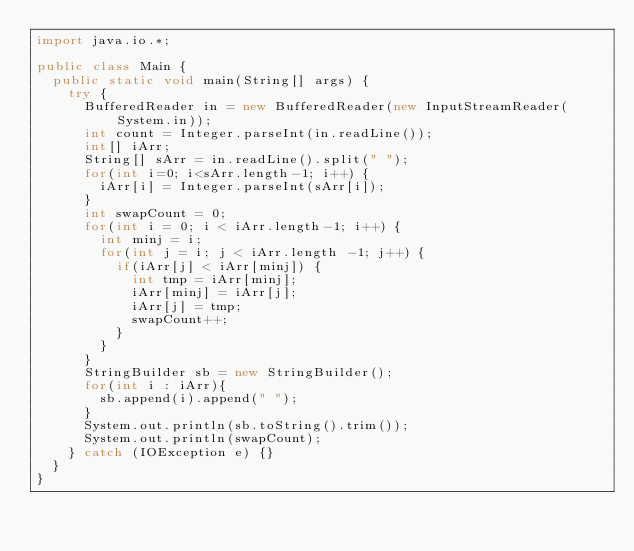<code> <loc_0><loc_0><loc_500><loc_500><_Java_>import java.io.*;

public class Main {
  public static void main(String[] args) {
    try {
      BufferedReader in = new BufferedReader(new InputStreamReader(System.in));
      int count = Integer.parseInt(in.readLine());
      int[] iArr;
      String[] sArr = in.readLine().split(" ");
      for(int i=0; i<sArr.length-1; i++) {
        iArr[i] = Integer.parseInt(sArr[i]);
      }
      int swapCount = 0;
      for(int i = 0; i < iArr.length-1; i++) {
        int minj = i;
        for(int j = i; j < iArr.length -1; j++) {
          if(iArr[j] < iArr[minj]) {
            int tmp = iArr[minj];
            iArr[minj] = iArr[j];
            iArr[j] = tmp;
            swapCount++;
          }
        }
      }
      StringBuilder sb = new StringBuilder();
      for(int i : iArr){
        sb.append(i).append(" ");
      }
      System.out.println(sb.toString().trim());
      System.out.println(swapCount);
    } catch (IOException e) {}
  }
}</code> 